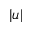Convert formula to latex. <formula><loc_0><loc_0><loc_500><loc_500>| u |</formula> 